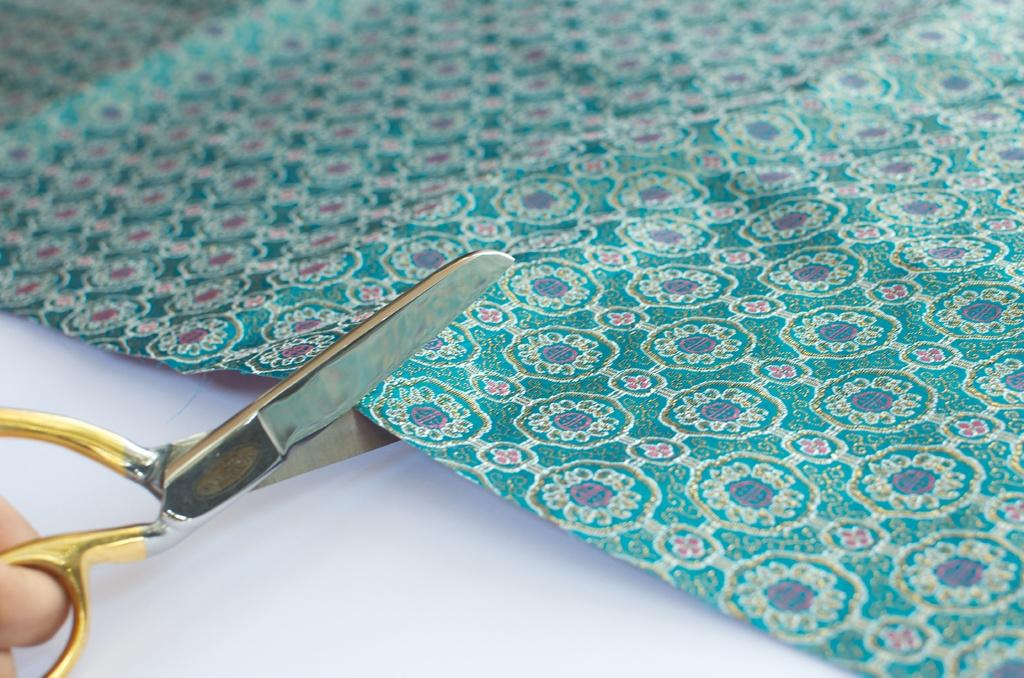What is the color of the surface in the image? The surface in the image is white colored. What is placed on the white surface? There is a green colored sheet on the surface. What is the person in the image doing? The person is holding scissors and cutting the sheet. What type of face can be seen on the sheet being cut by the person? There is no face visible on the sheet being cut in the image. 